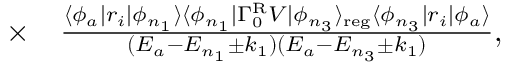<formula> <loc_0><loc_0><loc_500><loc_500>\begin{array} { r l } { \times } & \frac { \langle \phi _ { a } | r _ { i } | \phi _ { n _ { 1 } } \rangle \langle \phi _ { n _ { 1 } } | \Gamma _ { 0 } ^ { R } V | \phi _ { n _ { 3 } } \rangle _ { r e g } \langle \phi _ { n _ { 3 } } | r _ { i } | \phi _ { a } \rangle } { ( E _ { a } - E _ { n _ { 1 } } \pm k _ { 1 } ) ( E _ { a } - E _ { n _ { 3 } } \pm k _ { 1 } ) } , } \end{array}</formula> 